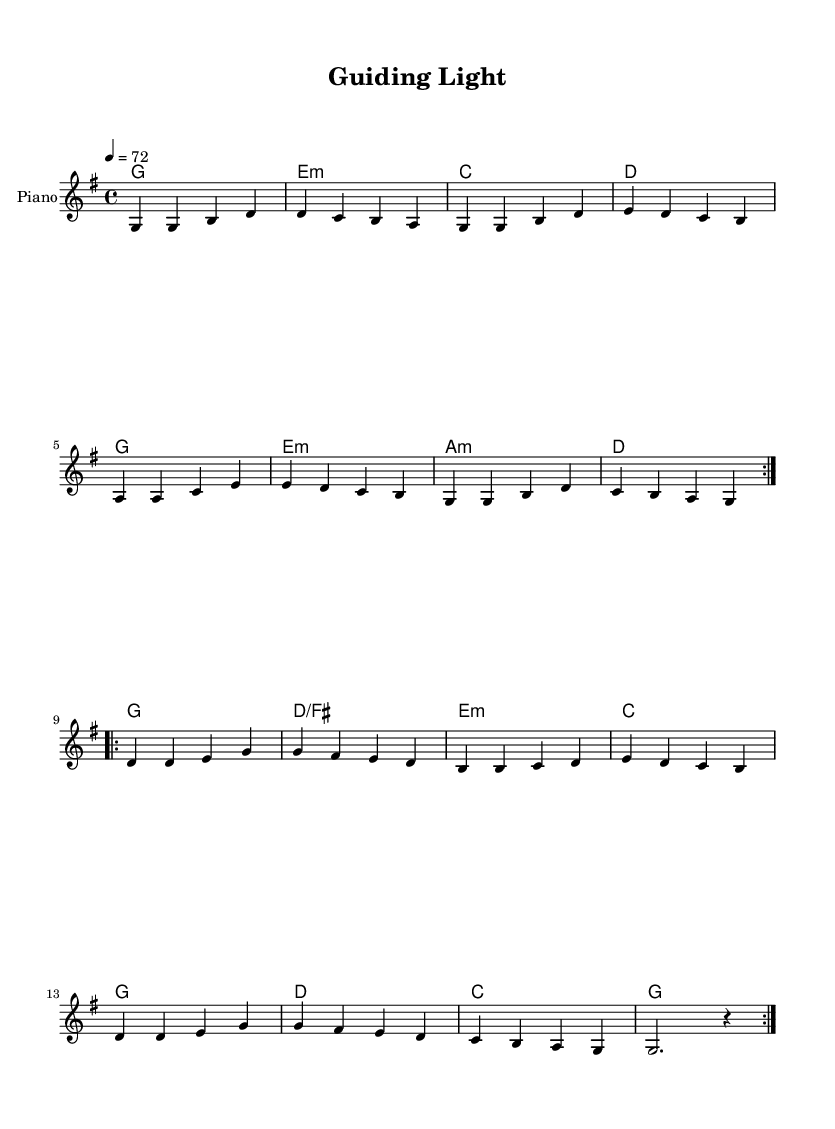What is the key signature of this music? The key signature is G major, indicated by one sharp (F#) which appears at the beginning of the staff.
Answer: G major What is the time signature of this music? The time signature is 4/4, which is shown at the beginning of the sheet music. Each measure contains four beats, and the quarter note gets one beat.
Answer: 4/4 What is the tempo of the piece? The tempo is marked as 72 beats per minute, indicated by the tempo marking shown in the score.
Answer: 72 How many times is the verse repeated? The verse is repeated twice as indicated by the repeat sign (volta) with a number 2.
Answer: 2 What type of emotions do the lyrics in the chorus evoke? The lyrics express feelings of inspiration and encouragement, promoting themes of growth and support, which is typical in mentor-mentee relationships in K-Pop ballads.
Answer: Inspiration What is the first note of the melody? The first note of the melody is G, which is the first note in the melody line as indicated in the score.
Answer: G Which musical instrument is featured in this score? The only instrument specified in the score is the piano, as indicated by the instrument name at the beginning of the staff.
Answer: Piano 